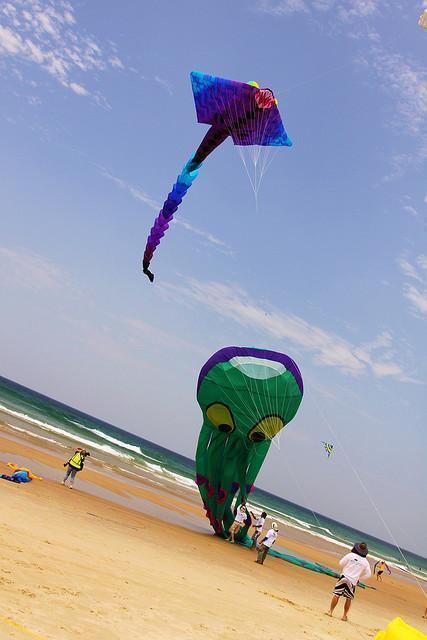How might the real version of the kite animal on top defend itself?
Make your selection and explain in format: 'Answer: answer
Rationale: rationale.'
Options: Hard shell, tusks, stinger, camouflage. Answer: stinger.
Rationale: There is a big animal. 